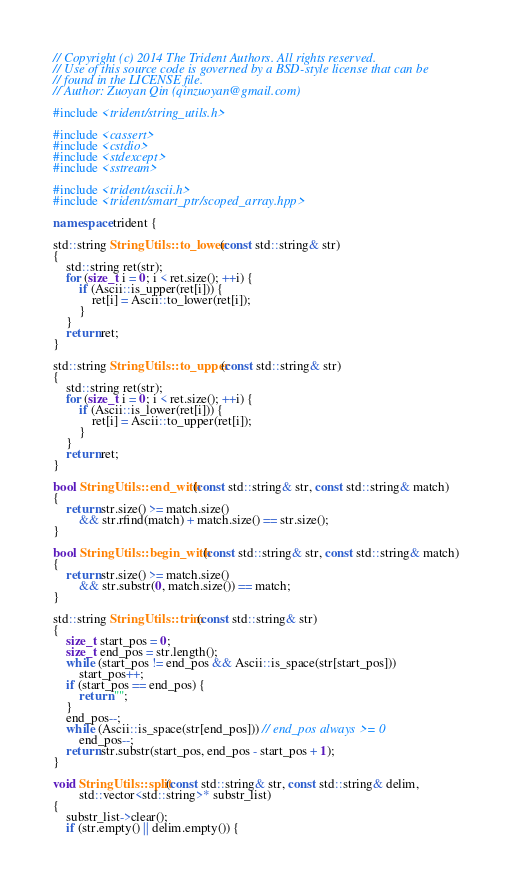<code> <loc_0><loc_0><loc_500><loc_500><_C++_>// Copyright (c) 2014 The Trident Authors. All rights reserved.
// Use of this source code is governed by a BSD-style license that can be
// found in the LICENSE file.
// Author: Zuoyan Qin (qinzuoyan@gmail.com)

#include <trident/string_utils.h>

#include <cassert>
#include <cstdio>
#include <stdexcept>
#include <sstream>

#include <trident/ascii.h>
#include <trident/smart_ptr/scoped_array.hpp>

namespace trident {

std::string StringUtils::to_lower(const std::string& str)
{
    std::string ret(str);
    for (size_t i = 0; i < ret.size(); ++i) {
        if (Ascii::is_upper(ret[i])) {
            ret[i] = Ascii::to_lower(ret[i]);
        }
    }
    return ret;
}

std::string StringUtils::to_upper(const std::string& str)
{
    std::string ret(str);
    for (size_t i = 0; i < ret.size(); ++i) {
        if (Ascii::is_lower(ret[i])) {
            ret[i] = Ascii::to_upper(ret[i]);
        }
    }
    return ret;
}

bool StringUtils::end_with(const std::string& str, const std::string& match)
{
    return str.size() >= match.size()
        && str.rfind(match) + match.size() == str.size();
}

bool StringUtils::begin_with(const std::string& str, const std::string& match)
{
    return str.size() >= match.size()
        && str.substr(0, match.size()) == match;
}

std::string StringUtils::trim(const std::string& str)
{
    size_t start_pos = 0;
    size_t end_pos = str.length();
    while (start_pos != end_pos && Ascii::is_space(str[start_pos]))
        start_pos++;
    if (start_pos == end_pos) {
        return "";
    }
    end_pos--;
    while (Ascii::is_space(str[end_pos])) // end_pos always >= 0
        end_pos--;
    return str.substr(start_pos, end_pos - start_pos + 1);
}

void StringUtils::split(const std::string& str, const std::string& delim,
        std::vector<std::string>* substr_list)
{
    substr_list->clear();
    if (str.empty() || delim.empty()) {</code> 